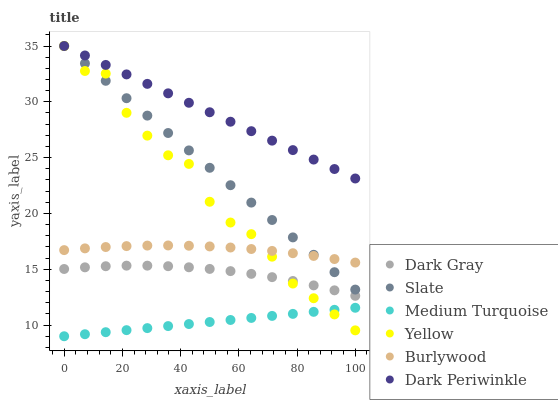Does Medium Turquoise have the minimum area under the curve?
Answer yes or no. Yes. Does Dark Periwinkle have the maximum area under the curve?
Answer yes or no. Yes. Does Slate have the minimum area under the curve?
Answer yes or no. No. Does Slate have the maximum area under the curve?
Answer yes or no. No. Is Medium Turquoise the smoothest?
Answer yes or no. Yes. Is Yellow the roughest?
Answer yes or no. Yes. Is Slate the smoothest?
Answer yes or no. No. Is Slate the roughest?
Answer yes or no. No. Does Medium Turquoise have the lowest value?
Answer yes or no. Yes. Does Slate have the lowest value?
Answer yes or no. No. Does Dark Periwinkle have the highest value?
Answer yes or no. Yes. Does Dark Gray have the highest value?
Answer yes or no. No. Is Medium Turquoise less than Burlywood?
Answer yes or no. Yes. Is Burlywood greater than Medium Turquoise?
Answer yes or no. Yes. Does Slate intersect Dark Periwinkle?
Answer yes or no. Yes. Is Slate less than Dark Periwinkle?
Answer yes or no. No. Is Slate greater than Dark Periwinkle?
Answer yes or no. No. Does Medium Turquoise intersect Burlywood?
Answer yes or no. No. 